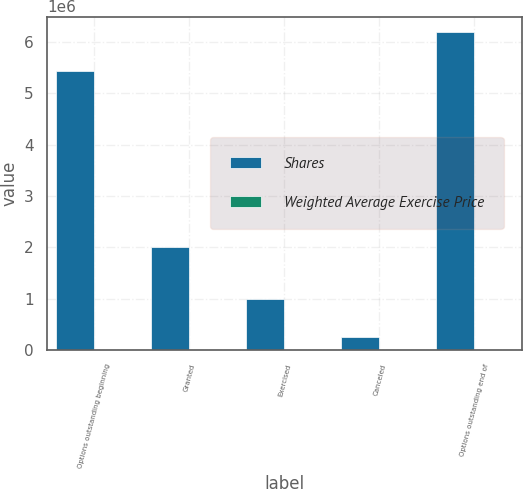Convert chart to OTSL. <chart><loc_0><loc_0><loc_500><loc_500><stacked_bar_chart><ecel><fcel>Options outstanding beginning<fcel>Granted<fcel>Exercised<fcel>Canceled<fcel>Options outstanding end of<nl><fcel>Shares<fcel>5.43806e+06<fcel>2.0065e+06<fcel>1.0031e+06<fcel>258444<fcel>6.18302e+06<nl><fcel>Weighted Average Exercise Price<fcel>6.91<fcel>20.86<fcel>3.76<fcel>10.63<fcel>11.78<nl></chart> 